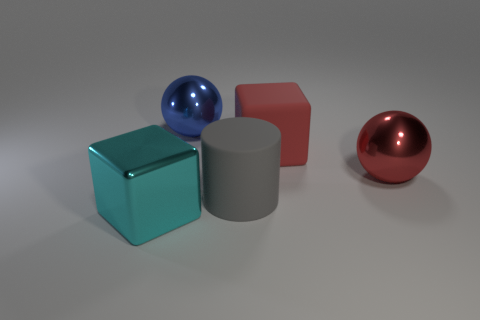Add 2 spheres. How many objects exist? 7 Subtract all cylinders. How many objects are left? 4 Subtract 0 green cylinders. How many objects are left? 5 Subtract all gray rubber cylinders. Subtract all big gray cylinders. How many objects are left? 3 Add 2 blue metal objects. How many blue metal objects are left? 3 Add 2 yellow metallic cylinders. How many yellow metallic cylinders exist? 2 